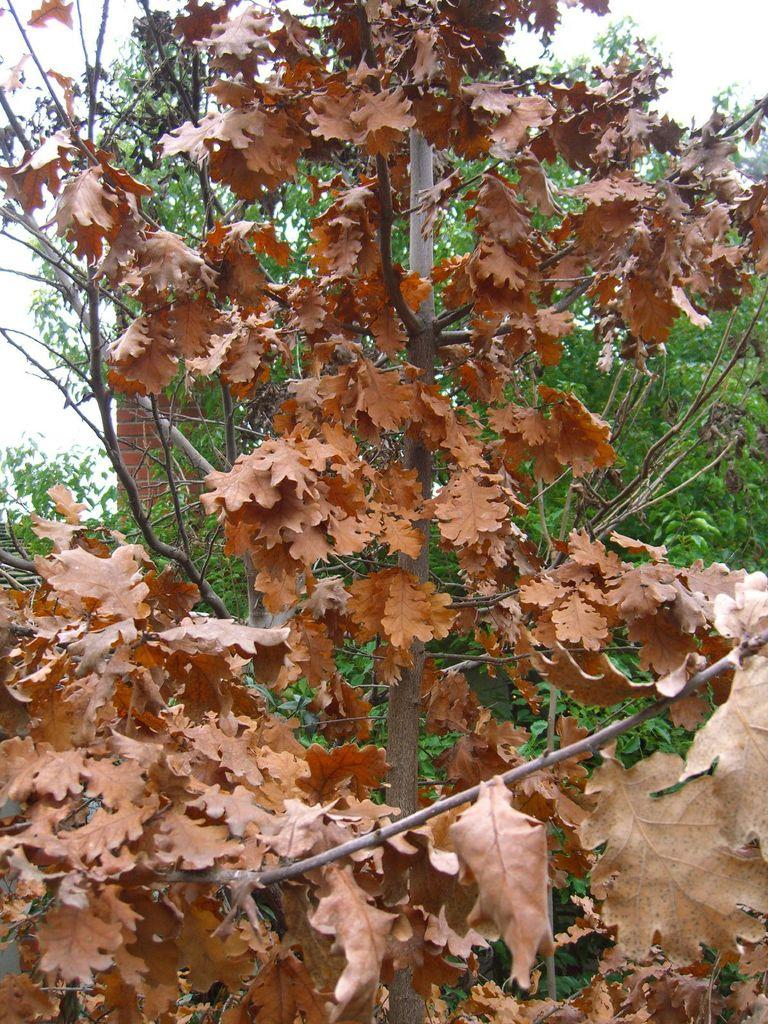What type of plant is visible in the image? There is a dried plant with dried leaves in the image. What can be seen in the background of the image? There is a tree and a brick wall in the background of the image. How many hammers are hanging on the tree in the image? There are no hammers present in the image; it features a dried plant, a tree, and a brick wall in the background. 